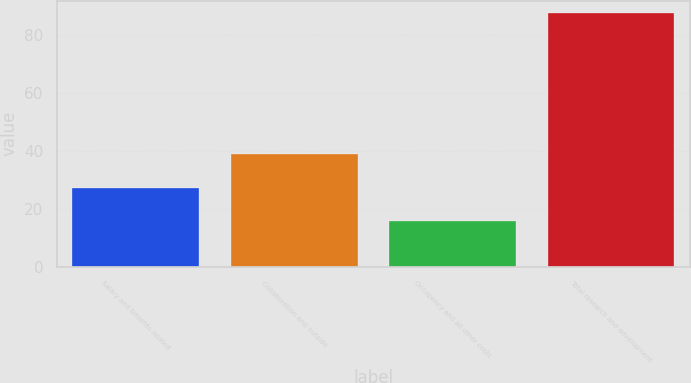<chart> <loc_0><loc_0><loc_500><loc_500><bar_chart><fcel>Salary and benefits related<fcel>Collaboration and outside<fcel>Occupancy and all other costs<fcel>Total research and development<nl><fcel>27.1<fcel>38.9<fcel>15.9<fcel>87.6<nl></chart> 